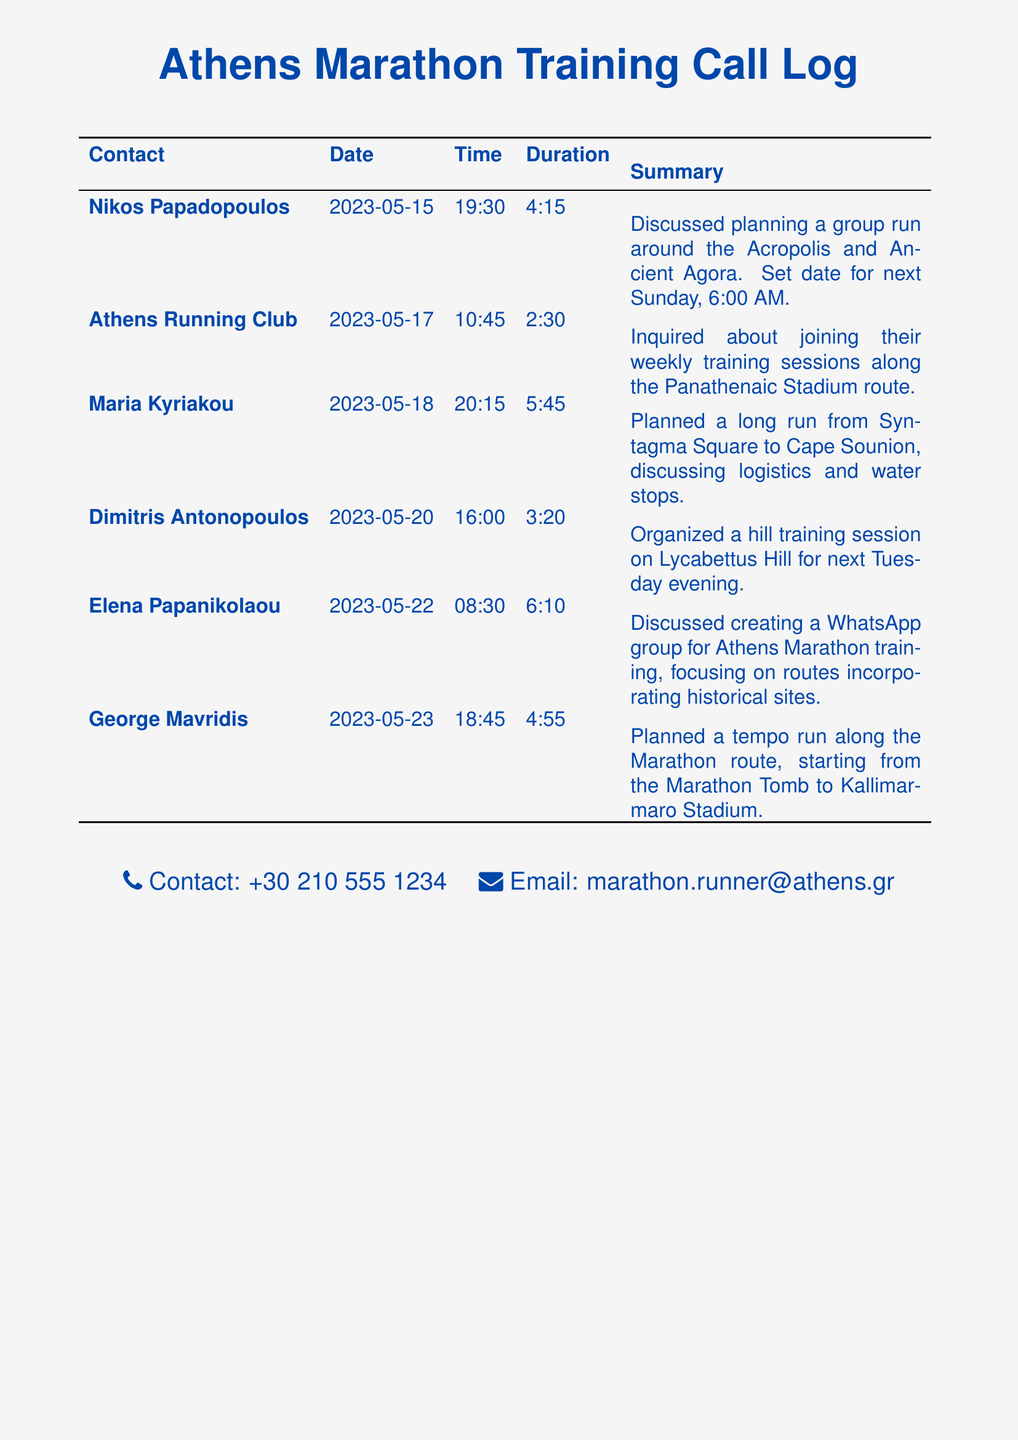What is the date of the call with Nikos Papadopoulos? The call with Nikos Papadopoulos took place on May 15, 2023.
Answer: 2023-05-15 How long was the call with Maria Kyriakou? The duration of the call with Maria Kyriakou was 5 hours and 45 minutes.
Answer: 5:45 What location is discussed for the long run with Maria Kyriakou? The planned long run with Maria Kyriakou is from Syntagma Square to Cape Sounion.
Answer: Syntagma Square to Cape Sounion Who organized the hill training session? Dimitris Antonopoulos organized the hill training session on Lycabettus Hill.
Answer: Dimitris Antonopoulos What time is the group run planned for next Sunday? The group run is scheduled for 6:00 AM next Sunday.
Answer: 6:00 AM What route will the tempo run take? The tempo run will take place along the Marathon route, from the Marathon Tomb to Kallimarmaro Stadium.
Answer: Marathon route Which contact in the log is associated with a WhatsApp group discussion? Elena Papanikolaou discussed creating a WhatsApp group for Athens Marathon training.
Answer: Elena Papanikolaou What is the total duration of the call with Elena Papanikolaou? The duration of the call with Elena Papanikolaou was 6 hours and 10 minutes.
Answer: 6:10 What type of calls are logged in this document? The document logs telephone records related to marathon training calls.
Answer: Marathon training calls 